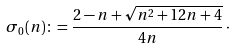<formula> <loc_0><loc_0><loc_500><loc_500>\sigma _ { 0 } ( n ) \colon = \frac { 2 - n + \sqrt { n ^ { 2 } + 1 2 n + 4 } } { 4 n } \, \cdot</formula> 